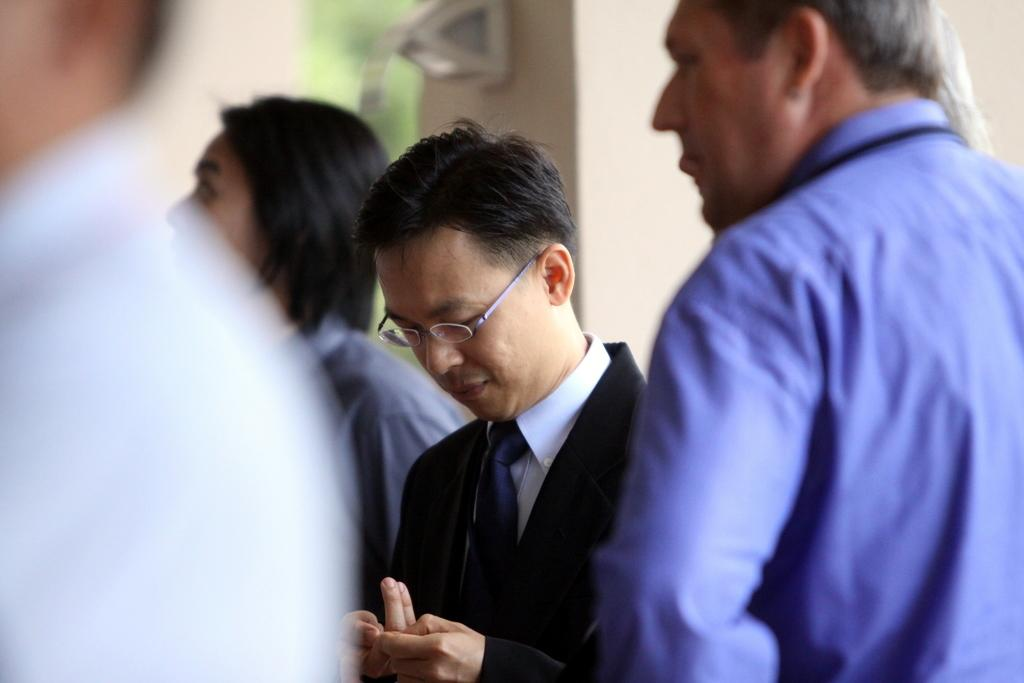How many people are in the image? There is a group of people standing in the image. Can you describe the device on the wall in the background of the image? Unfortunately, the provided facts do not give any details about the device on the wall. How many bulbs are on the man's head in the image? There is no man or bulbs present on anyone's head in the image. 